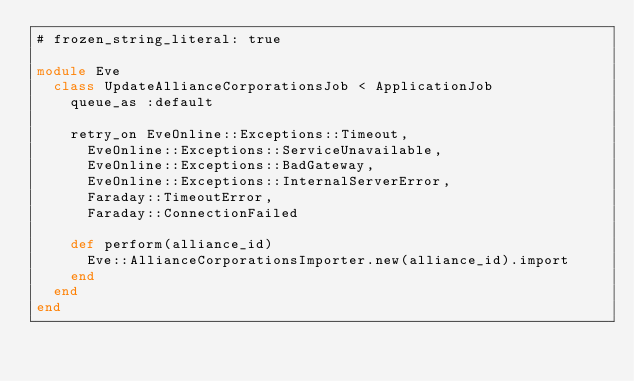Convert code to text. <code><loc_0><loc_0><loc_500><loc_500><_Ruby_># frozen_string_literal: true

module Eve
  class UpdateAllianceCorporationsJob < ApplicationJob
    queue_as :default

    retry_on EveOnline::Exceptions::Timeout,
      EveOnline::Exceptions::ServiceUnavailable,
      EveOnline::Exceptions::BadGateway,
      EveOnline::Exceptions::InternalServerError,
      Faraday::TimeoutError,
      Faraday::ConnectionFailed

    def perform(alliance_id)
      Eve::AllianceCorporationsImporter.new(alliance_id).import
    end
  end
end
</code> 